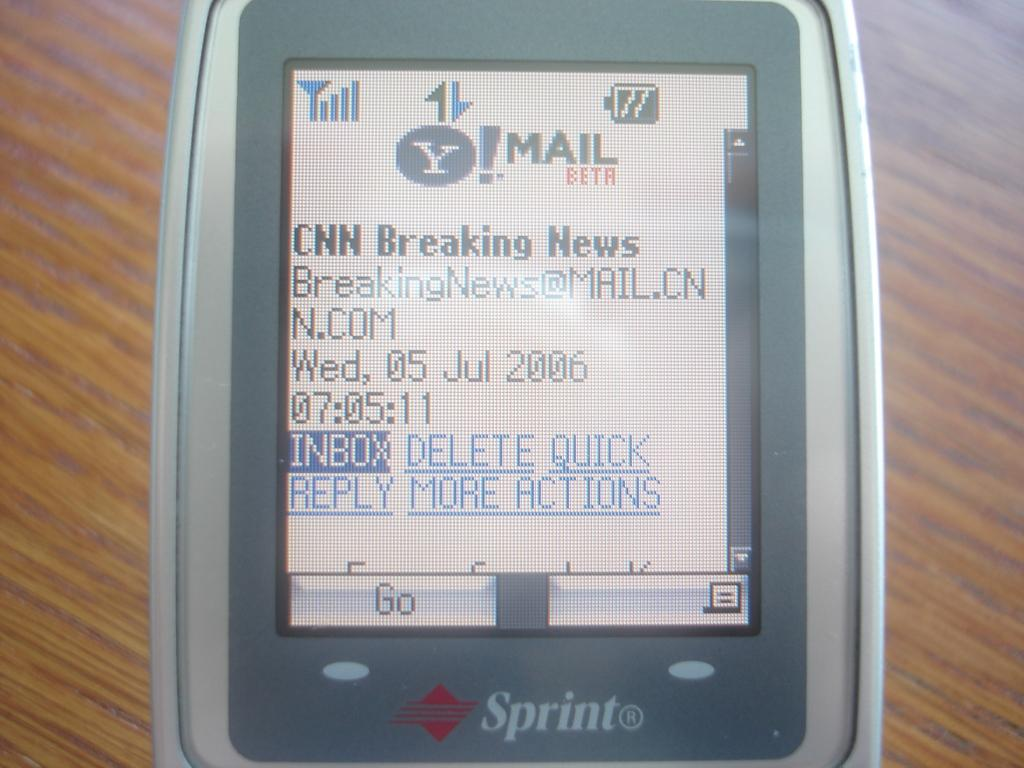Provide a one-sentence caption for the provided image. older sprint phone with cnn breaking news on screen and date of july 5, 2006. 